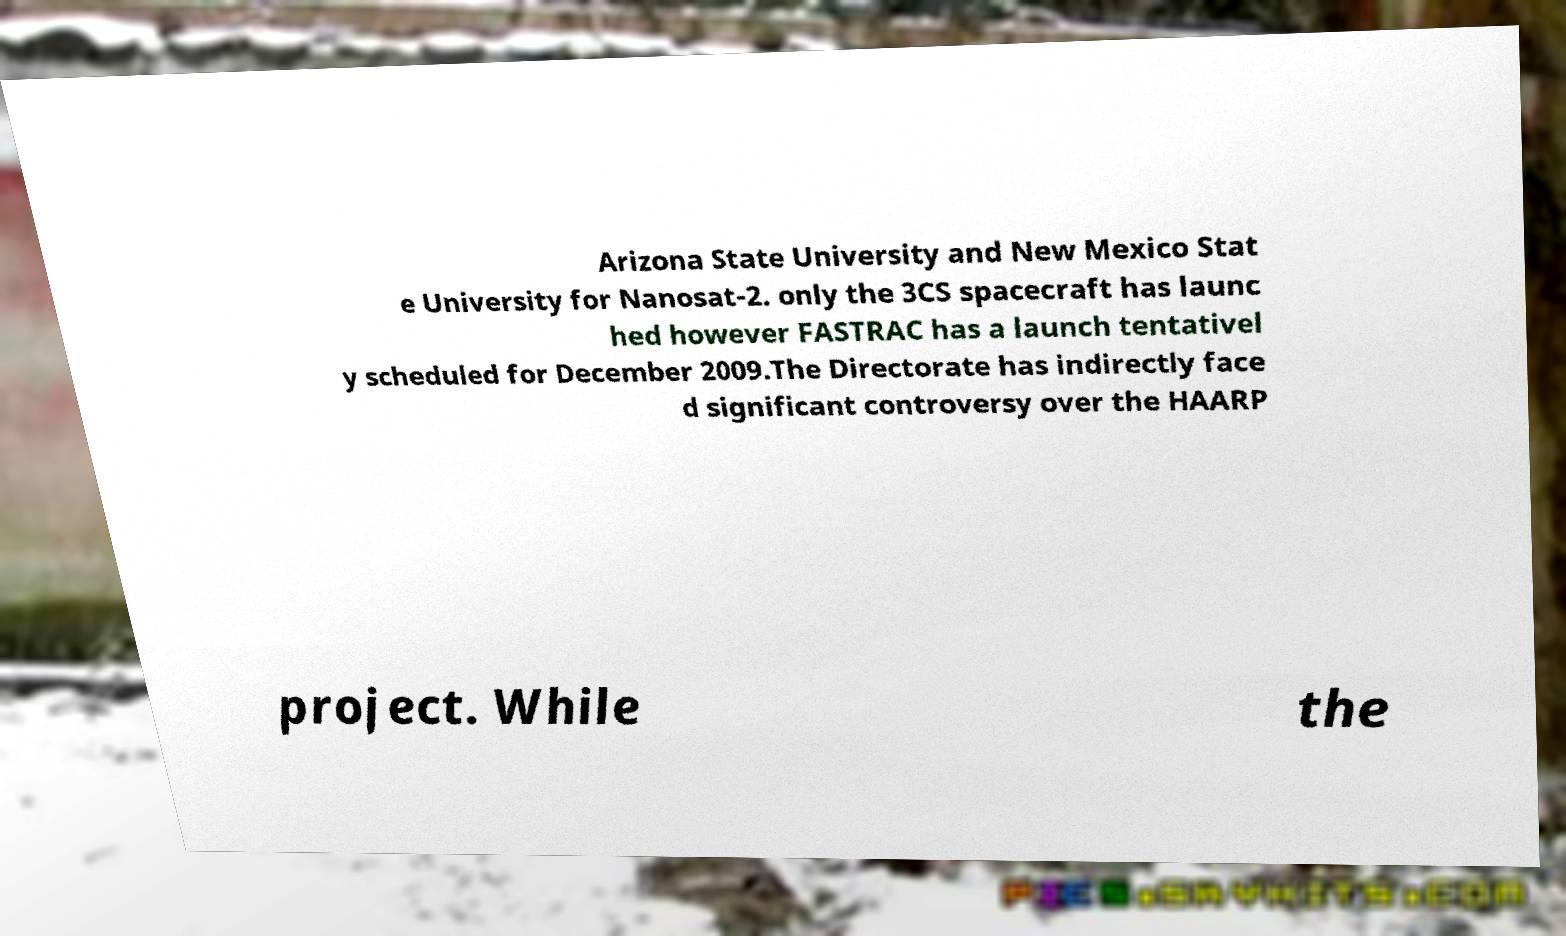I need the written content from this picture converted into text. Can you do that? Arizona State University and New Mexico Stat e University for Nanosat-2. only the 3CS spacecraft has launc hed however FASTRAC has a launch tentativel y scheduled for December 2009.The Directorate has indirectly face d significant controversy over the HAARP project. While the 